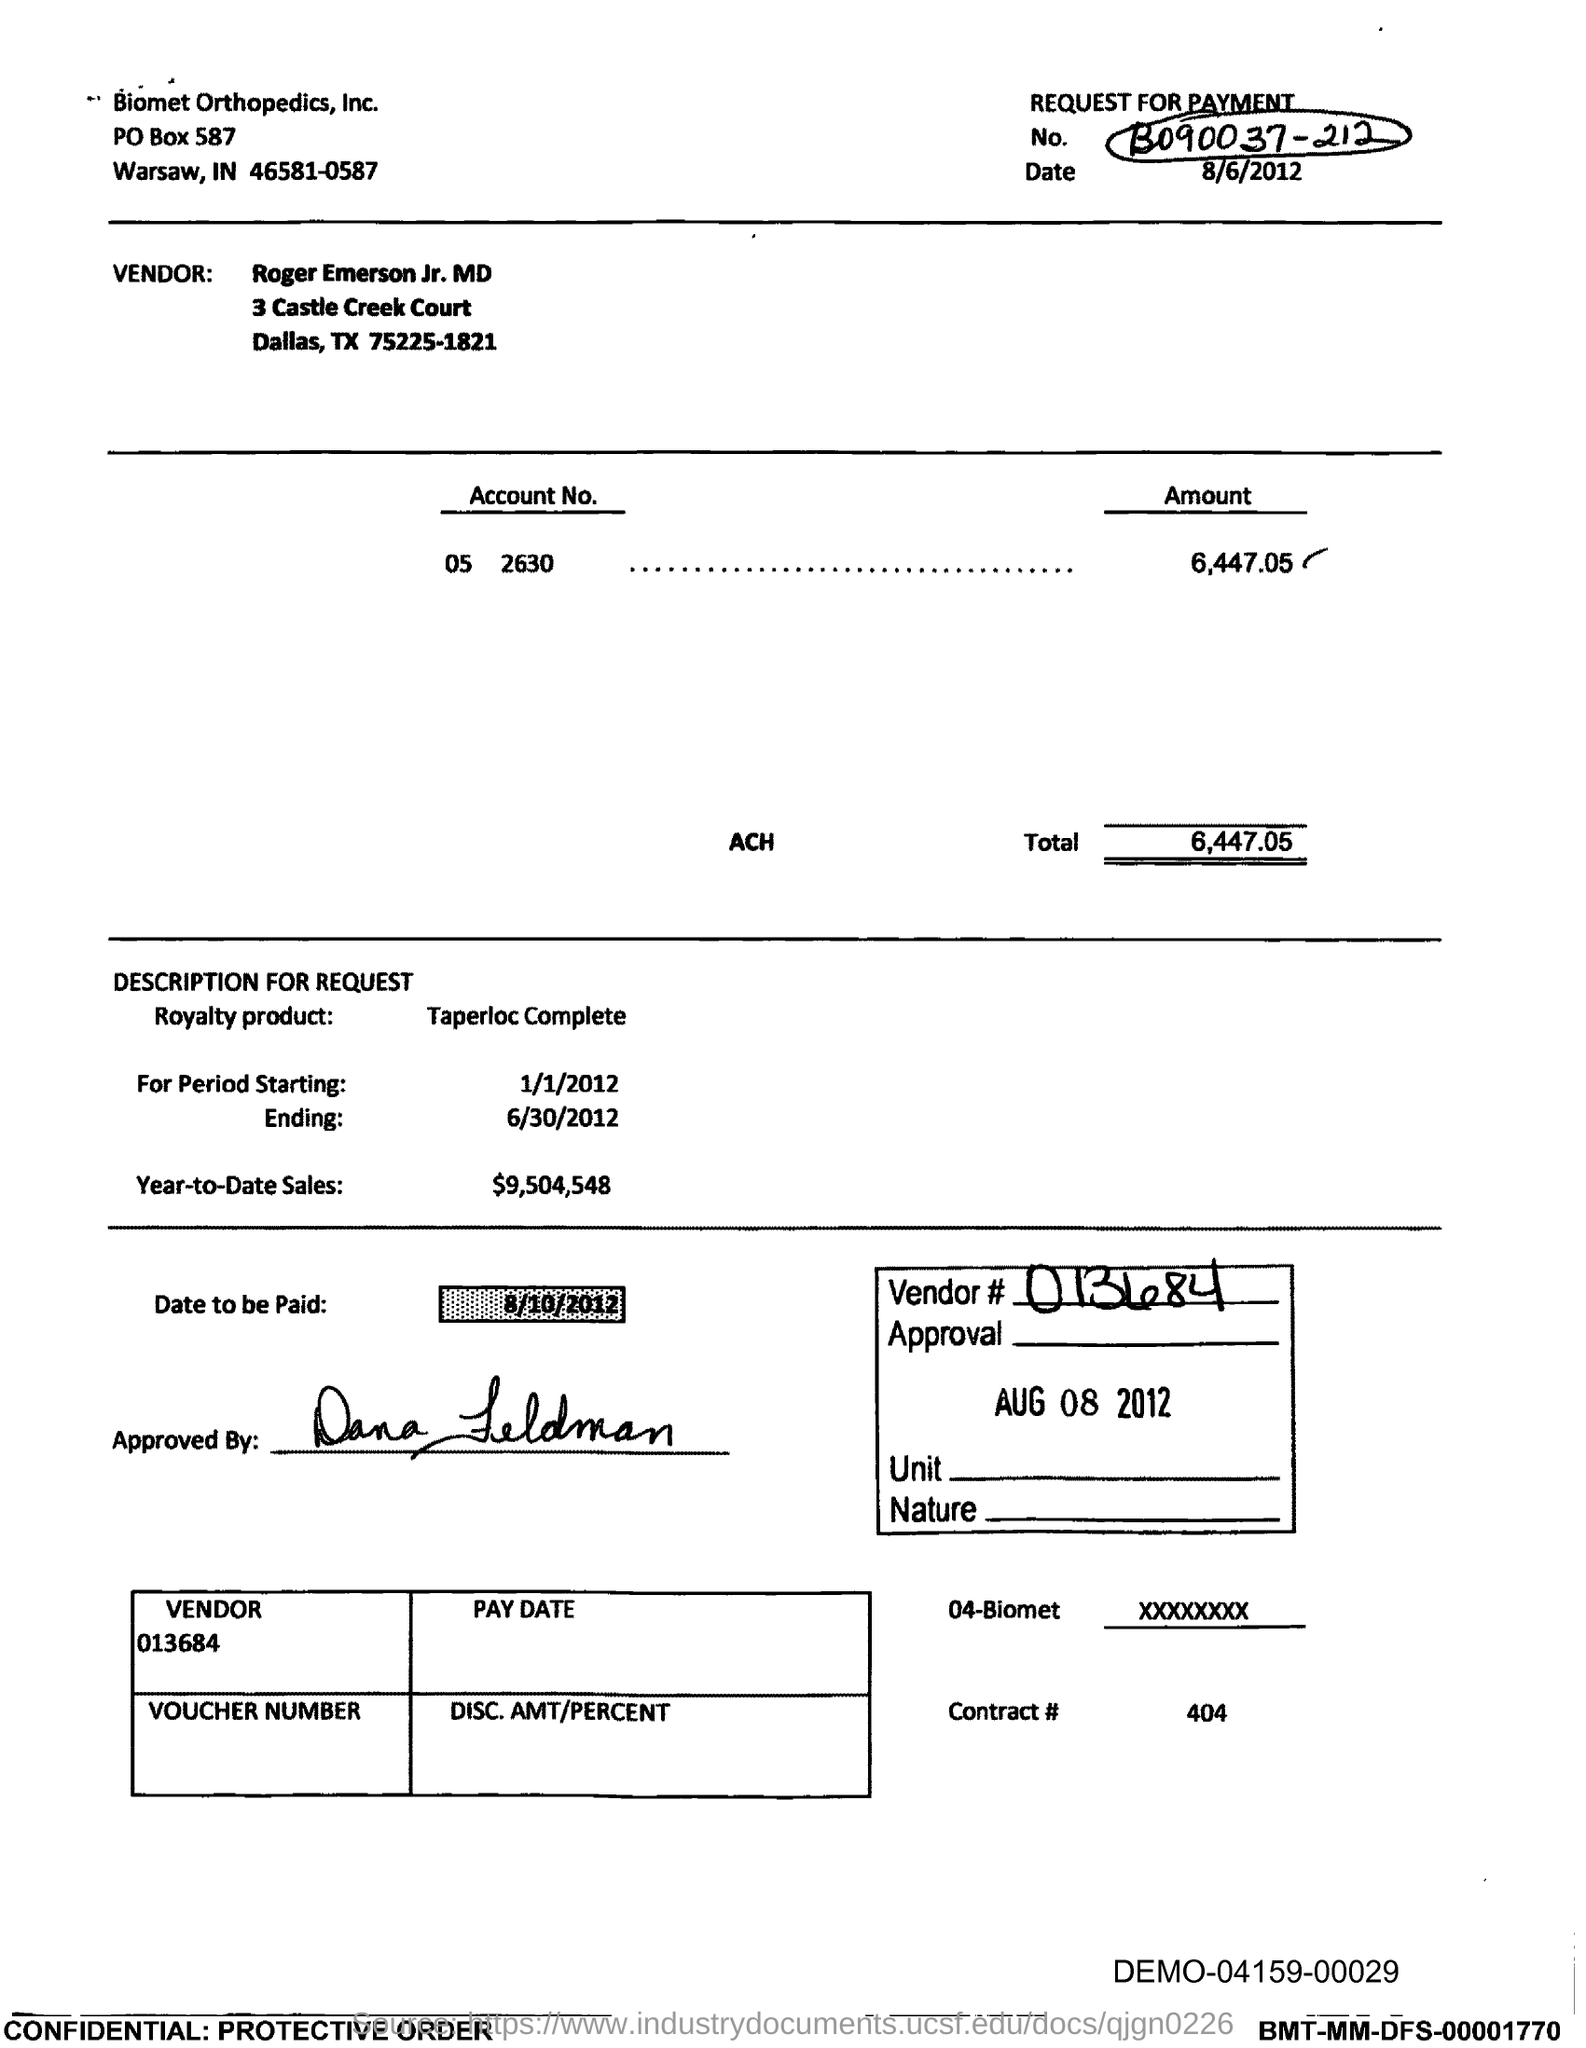Specify some key components in this picture. The product name is Taperloc Complete. Biomet Orthopedics, Inc. is located in the city of Warsaw. The PO Box number of Biomet Orthopedics, Inc. is 587. What is the date to be paid? Year-to-date sales, as of the current date, have reached a total of $9,504,548. 